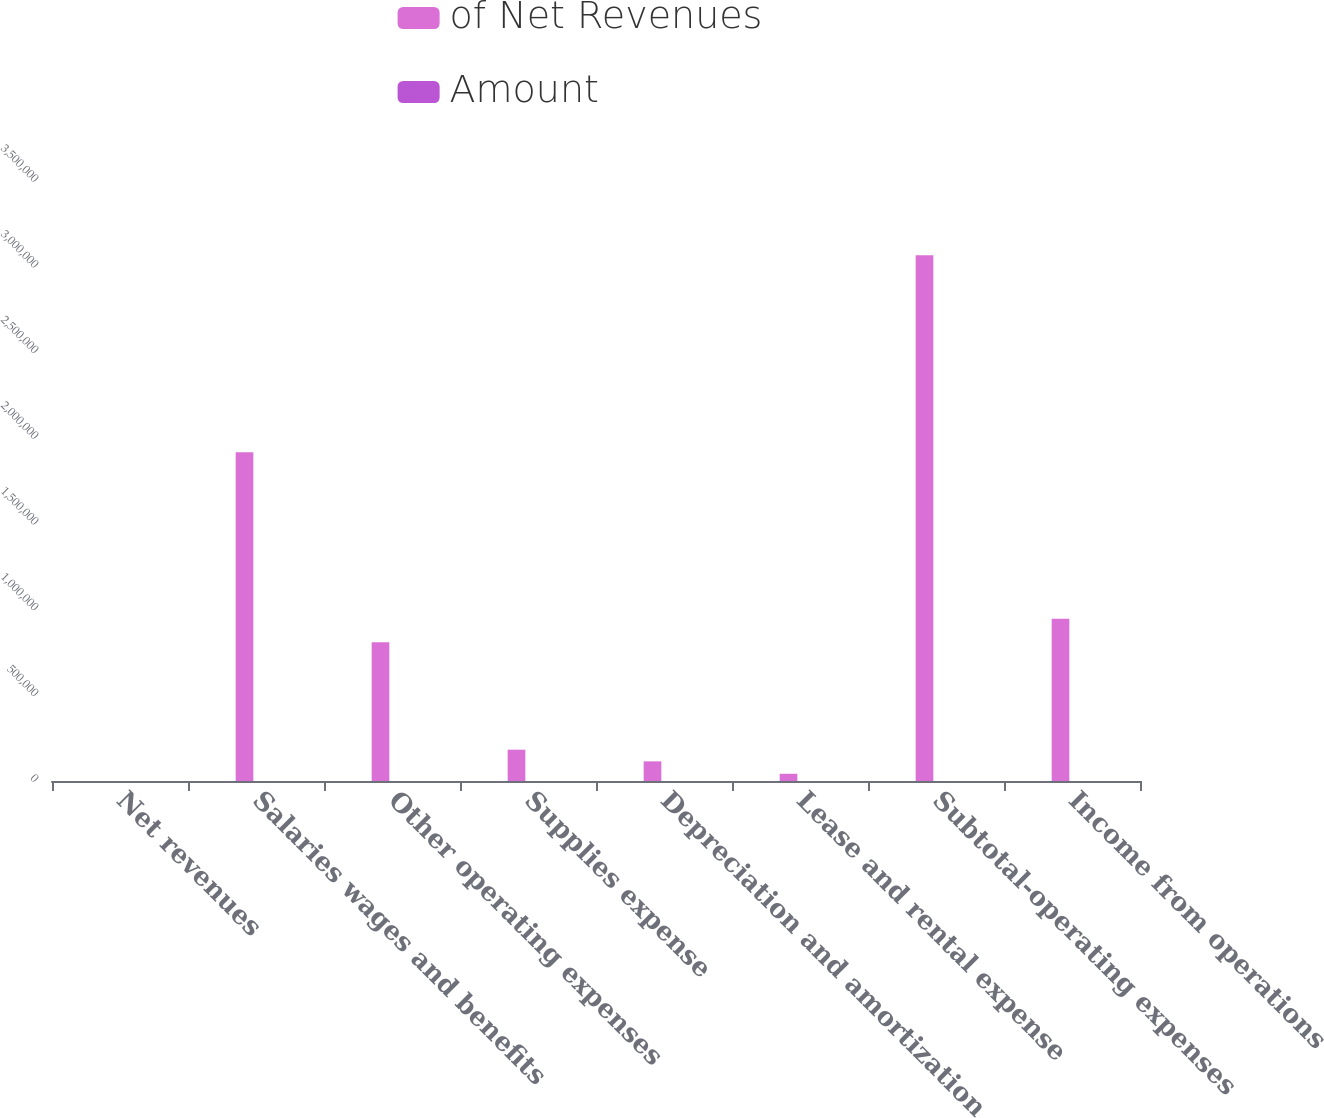<chart> <loc_0><loc_0><loc_500><loc_500><stacked_bar_chart><ecel><fcel>Net revenues<fcel>Salaries wages and benefits<fcel>Other operating expenses<fcel>Supplies expense<fcel>Depreciation and amortization<fcel>Lease and rental expense<fcel>Subtotal-operating expenses<fcel>Income from operations<nl><fcel>of Net Revenues<fcel>100<fcel>1.91793e+06<fcel>808894<fcel>182673<fcel>114599<fcel>42138<fcel>3.06623e+06<fcel>945985<nl><fcel>Amount<fcel>100<fcel>47.8<fcel>20.2<fcel>4.6<fcel>2.9<fcel>1.1<fcel>76.4<fcel>23.6<nl></chart> 